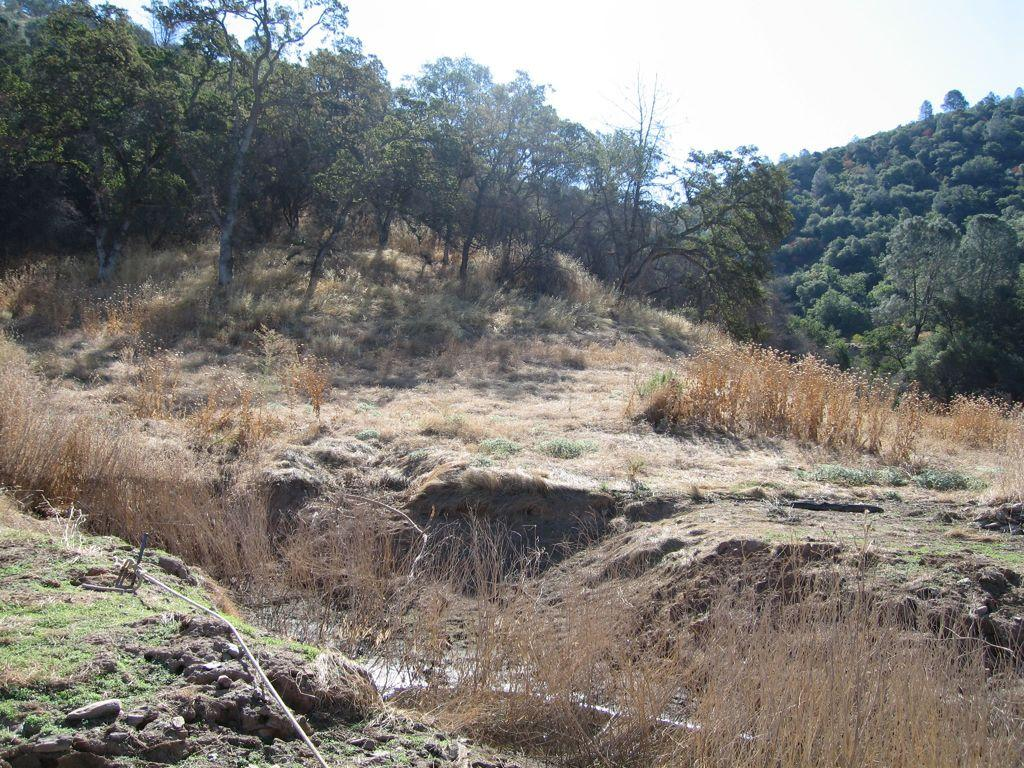What type of natural environment is depicted in the image? The image contains a forest. What type of vegetation can be seen in the forest? There is grass and trees in the forest. What is visible at the top of the image? The sky is visible at the top of the image. What object can be seen at the bottom of the image? There is a rope at the bottom of the image. Where are the cherries hanging in the image? There are no cherries present in the image. What type of loaf is being prepared in the forest? There is no loaf or any indication of food preparation in the image. 